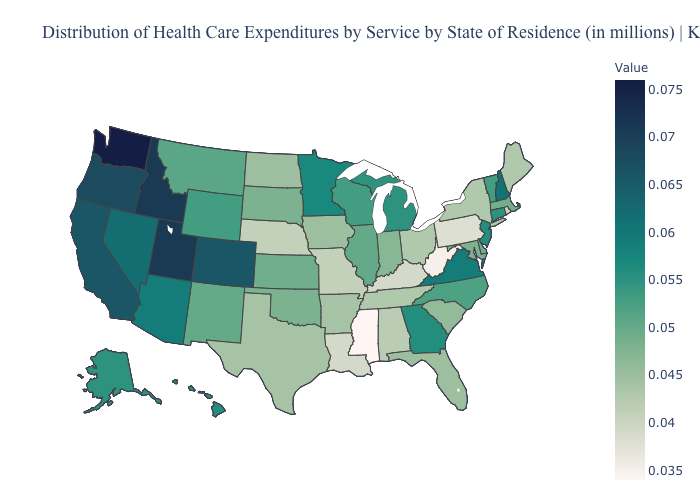Does Georgia have the lowest value in the USA?
Concise answer only. No. Among the states that border Mississippi , which have the lowest value?
Keep it brief. Louisiana. Is the legend a continuous bar?
Write a very short answer. Yes. Does Minnesota have a lower value than California?
Give a very brief answer. Yes. 